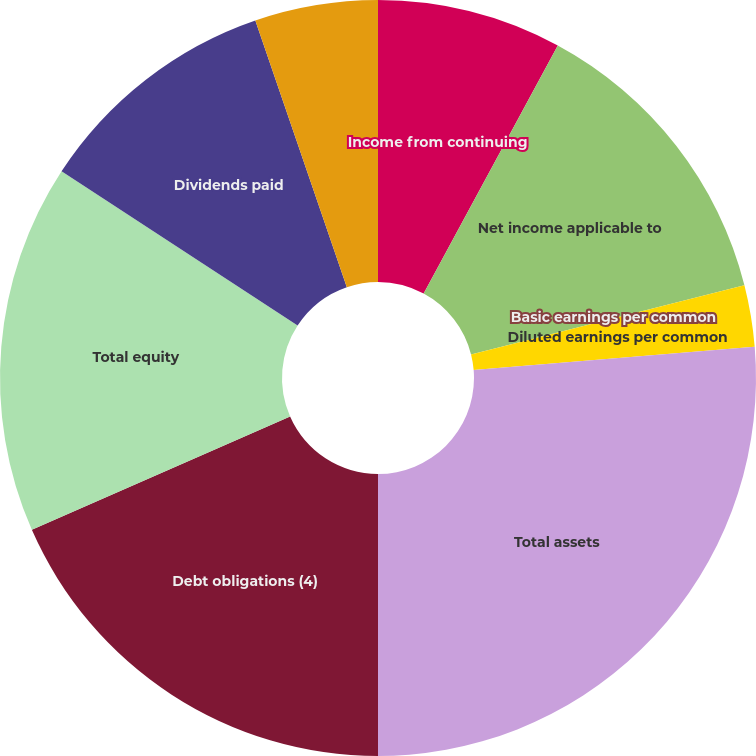<chart> <loc_0><loc_0><loc_500><loc_500><pie_chart><fcel>Income from continuing<fcel>Net income applicable to<fcel>Basic earnings per common<fcel>Diluted earnings per common<fcel>Total assets<fcel>Debt obligations (4)<fcel>Total equity<fcel>Dividends paid<fcel>Dividends paid per common<nl><fcel>7.89%<fcel>13.16%<fcel>0.0%<fcel>2.63%<fcel>26.32%<fcel>18.42%<fcel>15.79%<fcel>10.53%<fcel>5.26%<nl></chart> 